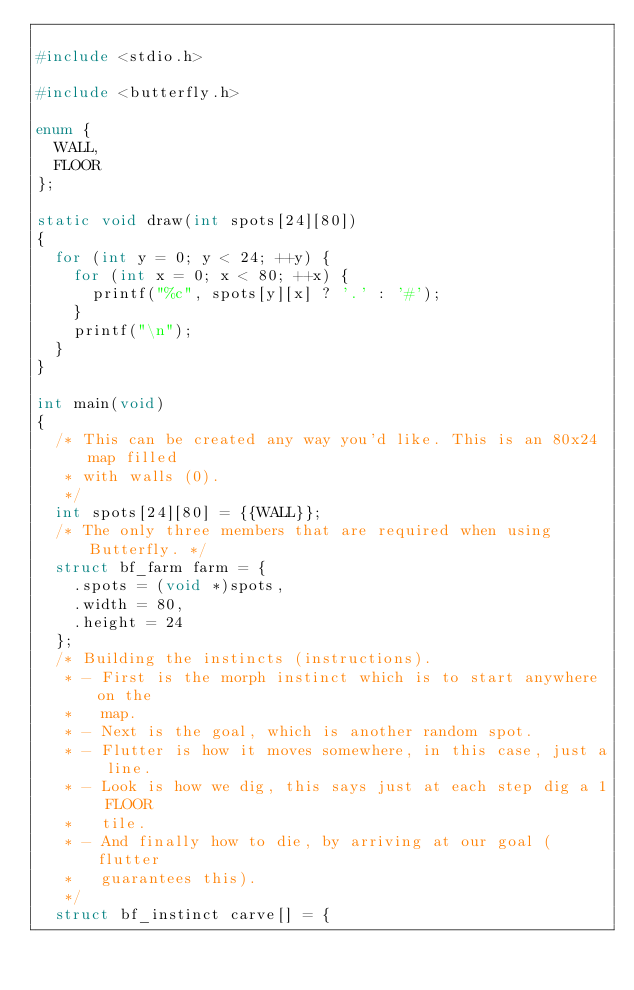<code> <loc_0><loc_0><loc_500><loc_500><_C_>
#include <stdio.h>

#include <butterfly.h>

enum {
	WALL,
	FLOOR
};

static void draw(int spots[24][80])
{
	for (int y = 0; y < 24; ++y) {
		for (int x = 0; x < 80; ++x) {
			printf("%c", spots[y][x] ? '.' : '#');
		}
		printf("\n");
	}
}

int main(void)
{
	/* This can be created any way you'd like. This is an 80x24 map filled
	 * with walls (0).
	 */
	int spots[24][80] = {{WALL}};
	/* The only three members that are required when using Butterfly. */
	struct bf_farm farm = {
		.spots = (void *)spots,
		.width = 80,
		.height = 24
	};
	/* Building the instincts (instructions).
	 * - First is the morph instinct which is to start anywhere on the
	 *   map.
	 * - Next is the goal, which is another random spot.
	 * - Flutter is how it moves somewhere, in this case, just a line.
	 * - Look is how we dig, this says just at each step dig a 1 FLOOR
	 *   tile.
	 * - And finally how to die, by arriving at our goal (flutter
	 *   guarantees this).
	 */
	struct bf_instinct carve[] = {</code> 